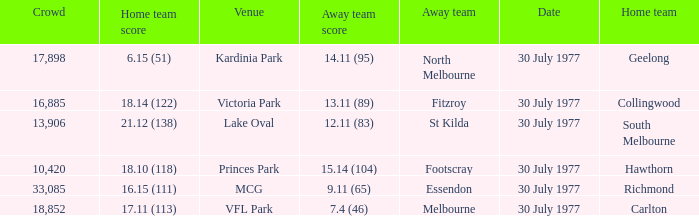Whom is the home team when the away team score is 9.11 (65)? Richmond. 